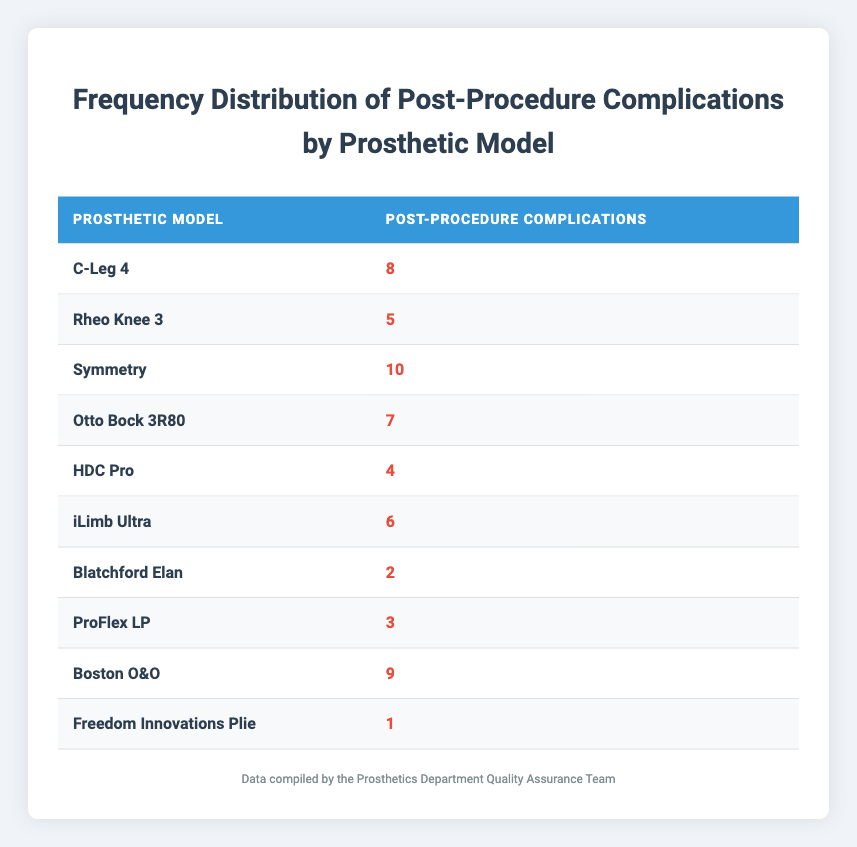What prosthetic model had the highest number of post-procedure complications? From the table, we can see each prosthetic model listed along with their respective post-procedure complications. The model "Symmetry" has 10 complications, which is the highest number compared to all other models.
Answer: Symmetry How many post-procedure complications did the "iLimb Ultra" model have? The specific number of complications for the "iLimb Ultra" model is directly listed in the table, and it shows 6 complications.
Answer: 6 What is the total number of post-procedure complications across all models? To find the total, we need to sum all the complications: 8 + 5 + 10 + 7 + 4 + 6 + 2 + 3 + 9 + 1 = 55. Therefore, the total number of complications is 55.
Answer: 55 Is there any prosthetic model with one post-procedure complication? Looking through the table, the "Freedom Innovations Plie" model has exactly 1 post-procedure complication listed, confirming that yes, there is a model with one complication.
Answer: Yes What is the average number of post-procedure complications for all prosthetic models? To calculate the average, first sum all the complications (55 as previously calculated). There are 10 models, so the average is 55 divided by 10, which equals 5.5.
Answer: 5.5 Which prosthetic model had the least number of post-procedure complications? By examining the table, we see that the "Blatchford Elan" model has the least number of complications with only 2 reported.
Answer: Blatchford Elan How many models had more than 5 post-procedure complications? We look at the table and see that the models "Symmetry" (10), "C-Leg 4" (8), "Boston O&O" (9), and "Otto Bock 3R80" (7) all have more than 5 complications. That totals 4 models.
Answer: 4 What is the difference in the number of complications between the model with the most and the model with the least complications? The model with the most complications is "Symmetry" with 10, and the model with the least is "Blatchford Elan" with 2. The difference is 10 - 2 = 8.
Answer: 8 Is the number of post-procedure complications for the "C-Leg 4" greater than that of the "Rheo Knee 3"? The "C-Leg 4" has 8 complications, while the "Rheo Knee 3" has only 5. Since 8 is greater than 5, the answer is yes.
Answer: Yes 